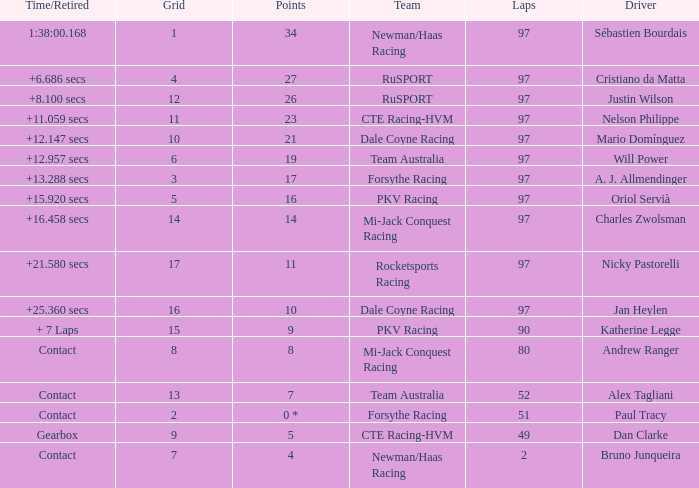What team does jan heylen race for? Dale Coyne Racing. 